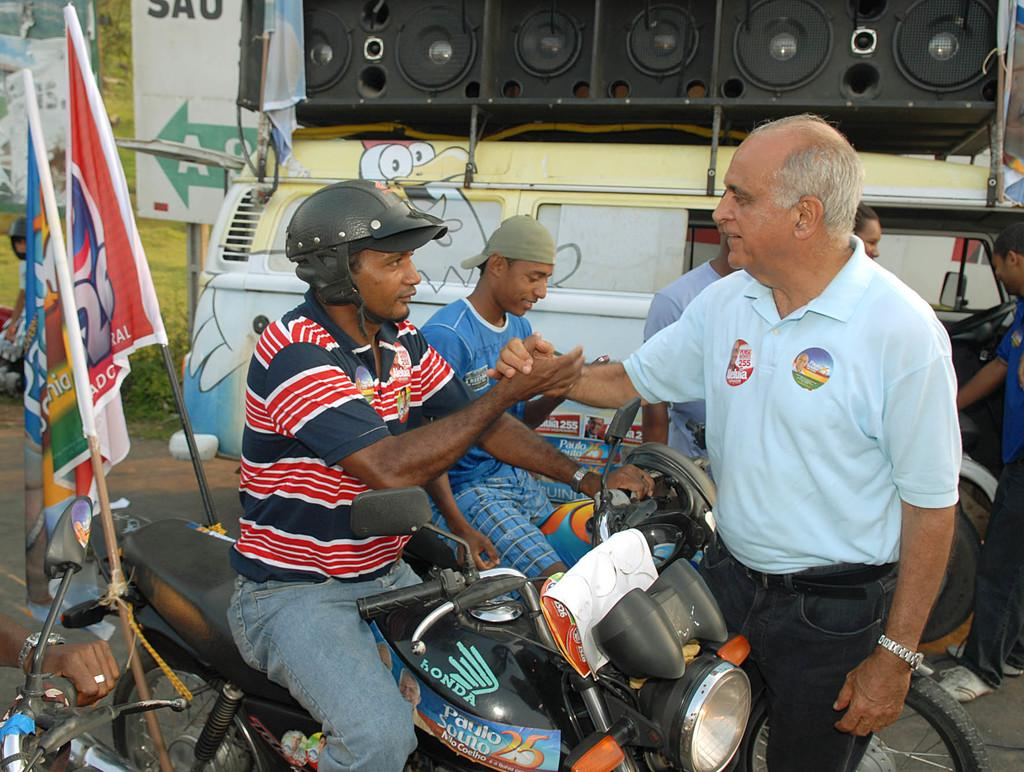How many people are riding the bike in the image? There are two men riding the bike in the image. What is happening between the two men on the bike and another person? There is a man talking to the two the two men on the bike. What other large vehicle can be seen in the image? There is a big bus in the image. What type of trousers are the ants wearing in the image? There are no ants or trousers present in the image. How many people are sitting on the sofa in the image? There is no sofa present in the image. 